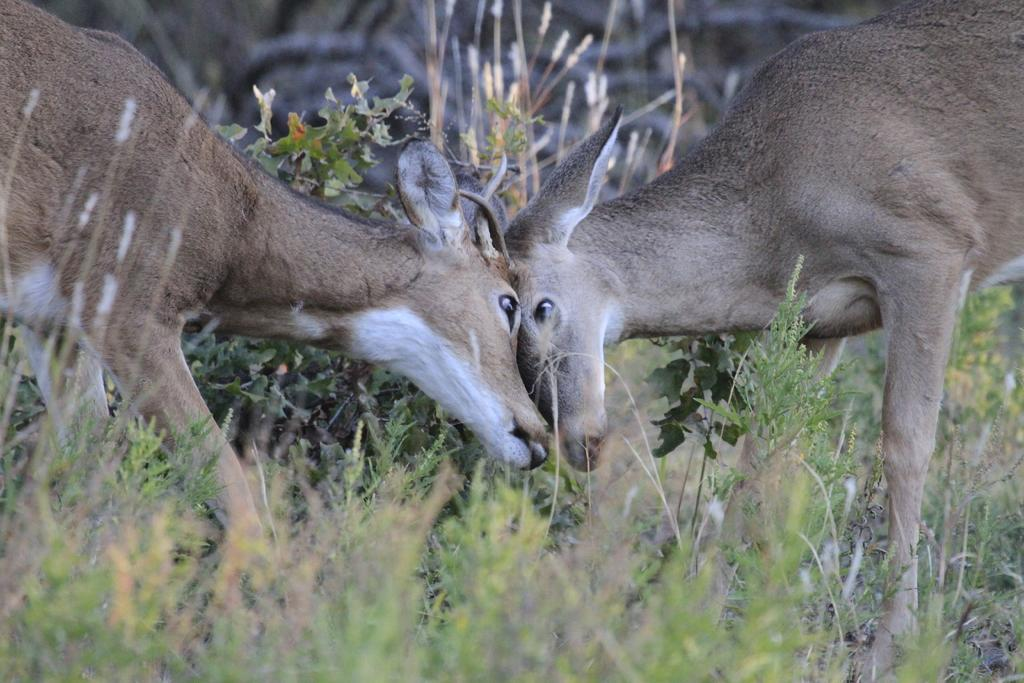How many animals are present in the image? There are two animals in the image. What else can be seen in the image besides the animals? There are plants in the image. What types of toys are scattered around the sea in the image? There is no sea or toys present in the image. What hobbies do the animals in the image engage in? The provided facts do not give any information about the animals' hobbies. 